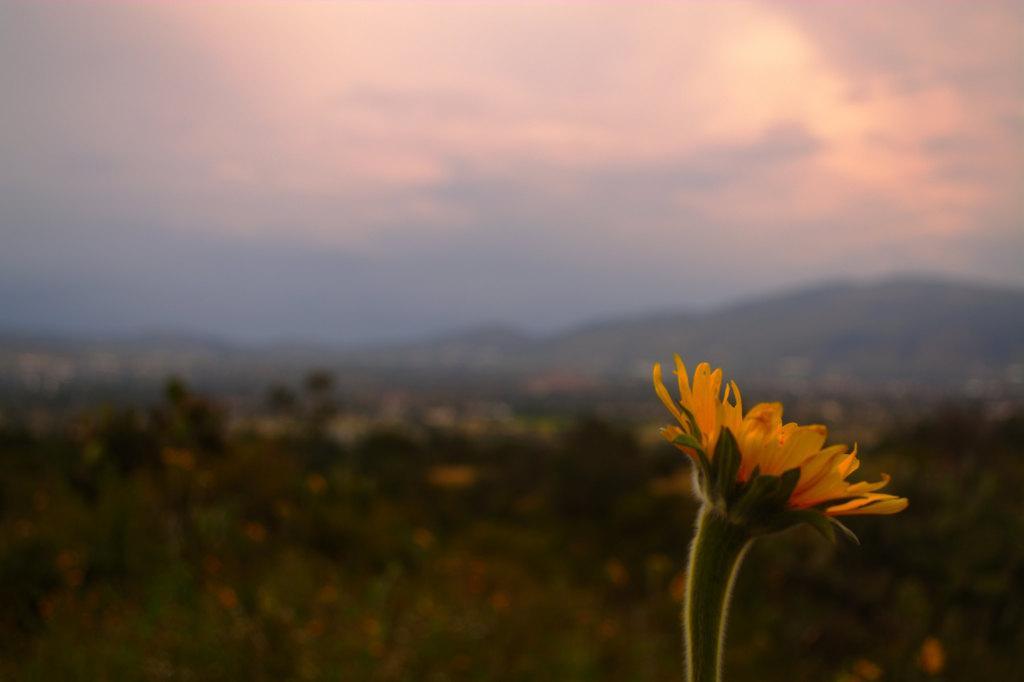Can you describe this image briefly? In the picture I can see two yellow color flowers. The background of the image is slightly blurred, where we can see trees, hills and the cloudy sky. 